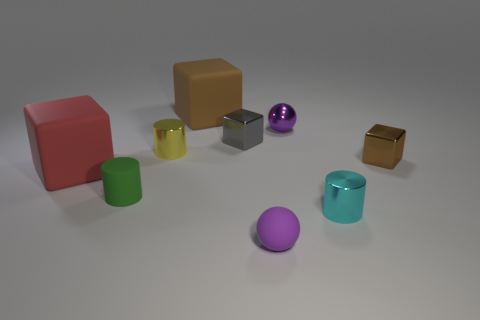Could you describe the different textures or materials you see among the objects? Absolutely. The objects in the image have a variety of textures and materials. The red and tan cubes, along with the two cylinders (one green and one teal), have a matte finish suggesting a possibly plastic or painted surface. In contrast, the smaller silver cube, golden-yellow box, and the small metallic purple sphere have a glossy, reflective metal-like surface. The matte finish gives the sense of softness, while the metallic glossiness suggests a harder, smoother material. 